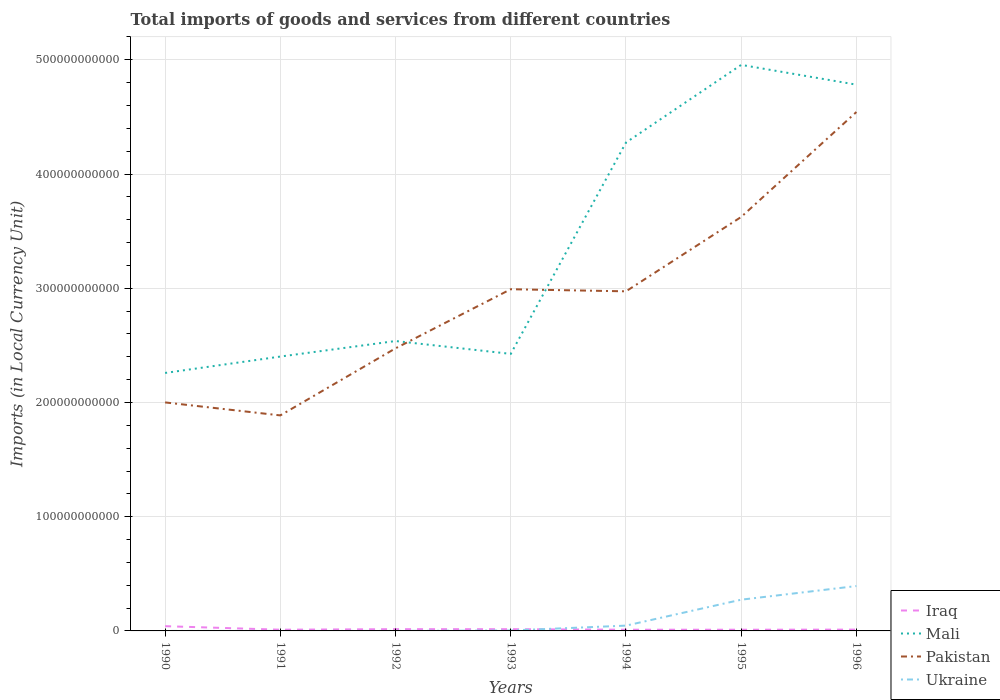How many different coloured lines are there?
Offer a very short reply. 4. Does the line corresponding to Ukraine intersect with the line corresponding to Pakistan?
Your answer should be compact. No. Across all years, what is the maximum Amount of goods and services imports in Mali?
Ensure brevity in your answer.  2.26e+11. What is the total Amount of goods and services imports in Ukraine in the graph?
Ensure brevity in your answer.  -3.93e+1. What is the difference between the highest and the second highest Amount of goods and services imports in Iraq?
Your answer should be compact. 3.11e+09. Is the Amount of goods and services imports in Ukraine strictly greater than the Amount of goods and services imports in Mali over the years?
Ensure brevity in your answer.  Yes. How many lines are there?
Give a very brief answer. 4. What is the difference between two consecutive major ticks on the Y-axis?
Ensure brevity in your answer.  1.00e+11. Does the graph contain any zero values?
Your answer should be very brief. No. Does the graph contain grids?
Give a very brief answer. Yes. How are the legend labels stacked?
Offer a terse response. Vertical. What is the title of the graph?
Provide a succinct answer. Total imports of goods and services from different countries. What is the label or title of the X-axis?
Make the answer very short. Years. What is the label or title of the Y-axis?
Offer a terse response. Imports (in Local Currency Unit). What is the Imports (in Local Currency Unit) of Iraq in 1990?
Your answer should be compact. 4.15e+09. What is the Imports (in Local Currency Unit) of Mali in 1990?
Give a very brief answer. 2.26e+11. What is the Imports (in Local Currency Unit) in Pakistan in 1990?
Make the answer very short. 2.00e+11. What is the Imports (in Local Currency Unit) of Ukraine in 1990?
Make the answer very short. 4.80e+05. What is the Imports (in Local Currency Unit) of Iraq in 1991?
Make the answer very short. 1.06e+09. What is the Imports (in Local Currency Unit) in Mali in 1991?
Make the answer very short. 2.40e+11. What is the Imports (in Local Currency Unit) of Pakistan in 1991?
Offer a terse response. 1.89e+11. What is the Imports (in Local Currency Unit) in Ukraine in 1991?
Offer a terse response. 7.17e+05. What is the Imports (in Local Currency Unit) in Iraq in 1992?
Keep it short and to the point. 1.54e+09. What is the Imports (in Local Currency Unit) of Mali in 1992?
Your response must be concise. 2.54e+11. What is the Imports (in Local Currency Unit) of Pakistan in 1992?
Offer a terse response. 2.47e+11. What is the Imports (in Local Currency Unit) in Ukraine in 1992?
Provide a short and direct response. 1.11e+07. What is the Imports (in Local Currency Unit) of Iraq in 1993?
Give a very brief answer. 1.51e+09. What is the Imports (in Local Currency Unit) of Mali in 1993?
Provide a succinct answer. 2.43e+11. What is the Imports (in Local Currency Unit) of Pakistan in 1993?
Provide a short and direct response. 2.99e+11. What is the Imports (in Local Currency Unit) in Ukraine in 1993?
Ensure brevity in your answer.  3.88e+08. What is the Imports (in Local Currency Unit) of Iraq in 1994?
Ensure brevity in your answer.  1.06e+09. What is the Imports (in Local Currency Unit) of Mali in 1994?
Give a very brief answer. 4.28e+11. What is the Imports (in Local Currency Unit) in Pakistan in 1994?
Make the answer very short. 2.97e+11. What is the Imports (in Local Currency Unit) in Ukraine in 1994?
Your response must be concise. 4.64e+09. What is the Imports (in Local Currency Unit) in Iraq in 1995?
Provide a succinct answer. 1.05e+09. What is the Imports (in Local Currency Unit) of Mali in 1995?
Your answer should be compact. 4.96e+11. What is the Imports (in Local Currency Unit) in Pakistan in 1995?
Give a very brief answer. 3.62e+11. What is the Imports (in Local Currency Unit) of Ukraine in 1995?
Your response must be concise. 2.73e+1. What is the Imports (in Local Currency Unit) of Iraq in 1996?
Ensure brevity in your answer.  1.15e+09. What is the Imports (in Local Currency Unit) in Mali in 1996?
Your answer should be compact. 4.78e+11. What is the Imports (in Local Currency Unit) in Pakistan in 1996?
Your answer should be very brief. 4.54e+11. What is the Imports (in Local Currency Unit) of Ukraine in 1996?
Keep it short and to the point. 3.93e+1. Across all years, what is the maximum Imports (in Local Currency Unit) in Iraq?
Provide a short and direct response. 4.15e+09. Across all years, what is the maximum Imports (in Local Currency Unit) in Mali?
Offer a very short reply. 4.96e+11. Across all years, what is the maximum Imports (in Local Currency Unit) of Pakistan?
Provide a short and direct response. 4.54e+11. Across all years, what is the maximum Imports (in Local Currency Unit) of Ukraine?
Offer a very short reply. 3.93e+1. Across all years, what is the minimum Imports (in Local Currency Unit) of Iraq?
Offer a very short reply. 1.05e+09. Across all years, what is the minimum Imports (in Local Currency Unit) of Mali?
Keep it short and to the point. 2.26e+11. Across all years, what is the minimum Imports (in Local Currency Unit) in Pakistan?
Offer a very short reply. 1.89e+11. Across all years, what is the minimum Imports (in Local Currency Unit) in Ukraine?
Your answer should be very brief. 4.80e+05. What is the total Imports (in Local Currency Unit) in Iraq in the graph?
Keep it short and to the point. 1.15e+1. What is the total Imports (in Local Currency Unit) of Mali in the graph?
Offer a terse response. 2.36e+12. What is the total Imports (in Local Currency Unit) of Pakistan in the graph?
Provide a succinct answer. 2.05e+12. What is the total Imports (in Local Currency Unit) in Ukraine in the graph?
Your answer should be compact. 7.17e+1. What is the difference between the Imports (in Local Currency Unit) of Iraq in 1990 and that in 1991?
Make the answer very short. 3.09e+09. What is the difference between the Imports (in Local Currency Unit) of Mali in 1990 and that in 1991?
Provide a short and direct response. -1.43e+1. What is the difference between the Imports (in Local Currency Unit) of Pakistan in 1990 and that in 1991?
Ensure brevity in your answer.  1.14e+1. What is the difference between the Imports (in Local Currency Unit) of Ukraine in 1990 and that in 1991?
Ensure brevity in your answer.  -2.37e+05. What is the difference between the Imports (in Local Currency Unit) of Iraq in 1990 and that in 1992?
Keep it short and to the point. 2.61e+09. What is the difference between the Imports (in Local Currency Unit) of Mali in 1990 and that in 1992?
Ensure brevity in your answer.  -2.79e+1. What is the difference between the Imports (in Local Currency Unit) in Pakistan in 1990 and that in 1992?
Provide a succinct answer. -4.74e+1. What is the difference between the Imports (in Local Currency Unit) of Ukraine in 1990 and that in 1992?
Provide a succinct answer. -1.06e+07. What is the difference between the Imports (in Local Currency Unit) in Iraq in 1990 and that in 1993?
Offer a very short reply. 2.65e+09. What is the difference between the Imports (in Local Currency Unit) in Mali in 1990 and that in 1993?
Your response must be concise. -1.67e+1. What is the difference between the Imports (in Local Currency Unit) of Pakistan in 1990 and that in 1993?
Provide a short and direct response. -9.91e+1. What is the difference between the Imports (in Local Currency Unit) in Ukraine in 1990 and that in 1993?
Your answer should be very brief. -3.88e+08. What is the difference between the Imports (in Local Currency Unit) in Iraq in 1990 and that in 1994?
Your response must be concise. 3.09e+09. What is the difference between the Imports (in Local Currency Unit) of Mali in 1990 and that in 1994?
Make the answer very short. -2.02e+11. What is the difference between the Imports (in Local Currency Unit) of Pakistan in 1990 and that in 1994?
Your response must be concise. -9.73e+1. What is the difference between the Imports (in Local Currency Unit) of Ukraine in 1990 and that in 1994?
Ensure brevity in your answer.  -4.64e+09. What is the difference between the Imports (in Local Currency Unit) of Iraq in 1990 and that in 1995?
Your answer should be very brief. 3.11e+09. What is the difference between the Imports (in Local Currency Unit) of Mali in 1990 and that in 1995?
Provide a succinct answer. -2.70e+11. What is the difference between the Imports (in Local Currency Unit) of Pakistan in 1990 and that in 1995?
Your response must be concise. -1.62e+11. What is the difference between the Imports (in Local Currency Unit) in Ukraine in 1990 and that in 1995?
Offer a very short reply. -2.73e+1. What is the difference between the Imports (in Local Currency Unit) in Iraq in 1990 and that in 1996?
Offer a terse response. 3.00e+09. What is the difference between the Imports (in Local Currency Unit) of Mali in 1990 and that in 1996?
Your response must be concise. -2.52e+11. What is the difference between the Imports (in Local Currency Unit) in Pakistan in 1990 and that in 1996?
Your answer should be compact. -2.54e+11. What is the difference between the Imports (in Local Currency Unit) in Ukraine in 1990 and that in 1996?
Keep it short and to the point. -3.93e+1. What is the difference between the Imports (in Local Currency Unit) in Iraq in 1991 and that in 1992?
Provide a short and direct response. -4.79e+08. What is the difference between the Imports (in Local Currency Unit) of Mali in 1991 and that in 1992?
Your answer should be compact. -1.36e+1. What is the difference between the Imports (in Local Currency Unit) in Pakistan in 1991 and that in 1992?
Ensure brevity in your answer.  -5.87e+1. What is the difference between the Imports (in Local Currency Unit) of Ukraine in 1991 and that in 1992?
Make the answer very short. -1.04e+07. What is the difference between the Imports (in Local Currency Unit) of Iraq in 1991 and that in 1993?
Provide a short and direct response. -4.47e+08. What is the difference between the Imports (in Local Currency Unit) of Mali in 1991 and that in 1993?
Ensure brevity in your answer.  -2.34e+09. What is the difference between the Imports (in Local Currency Unit) in Pakistan in 1991 and that in 1993?
Your answer should be compact. -1.10e+11. What is the difference between the Imports (in Local Currency Unit) in Ukraine in 1991 and that in 1993?
Give a very brief answer. -3.88e+08. What is the difference between the Imports (in Local Currency Unit) in Mali in 1991 and that in 1994?
Ensure brevity in your answer.  -1.87e+11. What is the difference between the Imports (in Local Currency Unit) of Pakistan in 1991 and that in 1994?
Your answer should be very brief. -1.09e+11. What is the difference between the Imports (in Local Currency Unit) in Ukraine in 1991 and that in 1994?
Your answer should be compact. -4.64e+09. What is the difference between the Imports (in Local Currency Unit) in Iraq in 1991 and that in 1995?
Ensure brevity in your answer.  1.56e+07. What is the difference between the Imports (in Local Currency Unit) of Mali in 1991 and that in 1995?
Make the answer very short. -2.55e+11. What is the difference between the Imports (in Local Currency Unit) in Pakistan in 1991 and that in 1995?
Your answer should be compact. -1.74e+11. What is the difference between the Imports (in Local Currency Unit) of Ukraine in 1991 and that in 1995?
Your answer should be compact. -2.73e+1. What is the difference between the Imports (in Local Currency Unit) of Iraq in 1991 and that in 1996?
Provide a succinct answer. -9.08e+07. What is the difference between the Imports (in Local Currency Unit) of Mali in 1991 and that in 1996?
Offer a very short reply. -2.38e+11. What is the difference between the Imports (in Local Currency Unit) of Pakistan in 1991 and that in 1996?
Provide a short and direct response. -2.66e+11. What is the difference between the Imports (in Local Currency Unit) in Ukraine in 1991 and that in 1996?
Offer a terse response. -3.93e+1. What is the difference between the Imports (in Local Currency Unit) of Iraq in 1992 and that in 1993?
Provide a short and direct response. 3.20e+07. What is the difference between the Imports (in Local Currency Unit) of Mali in 1992 and that in 1993?
Provide a succinct answer. 1.13e+1. What is the difference between the Imports (in Local Currency Unit) of Pakistan in 1992 and that in 1993?
Your answer should be very brief. -5.17e+1. What is the difference between the Imports (in Local Currency Unit) of Ukraine in 1992 and that in 1993?
Your answer should be very brief. -3.77e+08. What is the difference between the Imports (in Local Currency Unit) of Iraq in 1992 and that in 1994?
Offer a very short reply. 4.79e+08. What is the difference between the Imports (in Local Currency Unit) in Mali in 1992 and that in 1994?
Ensure brevity in your answer.  -1.74e+11. What is the difference between the Imports (in Local Currency Unit) in Pakistan in 1992 and that in 1994?
Your answer should be very brief. -4.99e+1. What is the difference between the Imports (in Local Currency Unit) in Ukraine in 1992 and that in 1994?
Your response must be concise. -4.63e+09. What is the difference between the Imports (in Local Currency Unit) of Iraq in 1992 and that in 1995?
Give a very brief answer. 4.95e+08. What is the difference between the Imports (in Local Currency Unit) of Mali in 1992 and that in 1995?
Your answer should be compact. -2.42e+11. What is the difference between the Imports (in Local Currency Unit) of Pakistan in 1992 and that in 1995?
Give a very brief answer. -1.15e+11. What is the difference between the Imports (in Local Currency Unit) of Ukraine in 1992 and that in 1995?
Give a very brief answer. -2.73e+1. What is the difference between the Imports (in Local Currency Unit) in Iraq in 1992 and that in 1996?
Your answer should be compact. 3.89e+08. What is the difference between the Imports (in Local Currency Unit) of Mali in 1992 and that in 1996?
Ensure brevity in your answer.  -2.24e+11. What is the difference between the Imports (in Local Currency Unit) in Pakistan in 1992 and that in 1996?
Ensure brevity in your answer.  -2.07e+11. What is the difference between the Imports (in Local Currency Unit) of Ukraine in 1992 and that in 1996?
Your answer should be very brief. -3.93e+1. What is the difference between the Imports (in Local Currency Unit) in Iraq in 1993 and that in 1994?
Provide a succinct answer. 4.47e+08. What is the difference between the Imports (in Local Currency Unit) of Mali in 1993 and that in 1994?
Offer a terse response. -1.85e+11. What is the difference between the Imports (in Local Currency Unit) of Pakistan in 1993 and that in 1994?
Your response must be concise. 1.84e+09. What is the difference between the Imports (in Local Currency Unit) of Ukraine in 1993 and that in 1994?
Make the answer very short. -4.25e+09. What is the difference between the Imports (in Local Currency Unit) of Iraq in 1993 and that in 1995?
Keep it short and to the point. 4.63e+08. What is the difference between the Imports (in Local Currency Unit) in Mali in 1993 and that in 1995?
Give a very brief answer. -2.53e+11. What is the difference between the Imports (in Local Currency Unit) in Pakistan in 1993 and that in 1995?
Keep it short and to the point. -6.33e+1. What is the difference between the Imports (in Local Currency Unit) of Ukraine in 1993 and that in 1995?
Provide a short and direct response. -2.70e+1. What is the difference between the Imports (in Local Currency Unit) in Iraq in 1993 and that in 1996?
Provide a succinct answer. 3.57e+08. What is the difference between the Imports (in Local Currency Unit) of Mali in 1993 and that in 1996?
Your answer should be compact. -2.36e+11. What is the difference between the Imports (in Local Currency Unit) of Pakistan in 1993 and that in 1996?
Make the answer very short. -1.55e+11. What is the difference between the Imports (in Local Currency Unit) in Ukraine in 1993 and that in 1996?
Give a very brief answer. -3.89e+1. What is the difference between the Imports (in Local Currency Unit) in Iraq in 1994 and that in 1995?
Your answer should be compact. 1.56e+07. What is the difference between the Imports (in Local Currency Unit) in Mali in 1994 and that in 1995?
Offer a terse response. -6.80e+1. What is the difference between the Imports (in Local Currency Unit) in Pakistan in 1994 and that in 1995?
Keep it short and to the point. -6.51e+1. What is the difference between the Imports (in Local Currency Unit) of Ukraine in 1994 and that in 1995?
Provide a short and direct response. -2.27e+1. What is the difference between the Imports (in Local Currency Unit) of Iraq in 1994 and that in 1996?
Make the answer very short. -9.08e+07. What is the difference between the Imports (in Local Currency Unit) of Mali in 1994 and that in 1996?
Your answer should be compact. -5.07e+1. What is the difference between the Imports (in Local Currency Unit) in Pakistan in 1994 and that in 1996?
Ensure brevity in your answer.  -1.57e+11. What is the difference between the Imports (in Local Currency Unit) of Ukraine in 1994 and that in 1996?
Keep it short and to the point. -3.47e+1. What is the difference between the Imports (in Local Currency Unit) of Iraq in 1995 and that in 1996?
Make the answer very short. -1.06e+08. What is the difference between the Imports (in Local Currency Unit) in Mali in 1995 and that in 1996?
Keep it short and to the point. 1.73e+1. What is the difference between the Imports (in Local Currency Unit) in Pakistan in 1995 and that in 1996?
Provide a short and direct response. -9.19e+1. What is the difference between the Imports (in Local Currency Unit) of Ukraine in 1995 and that in 1996?
Offer a very short reply. -1.20e+1. What is the difference between the Imports (in Local Currency Unit) in Iraq in 1990 and the Imports (in Local Currency Unit) in Mali in 1991?
Make the answer very short. -2.36e+11. What is the difference between the Imports (in Local Currency Unit) of Iraq in 1990 and the Imports (in Local Currency Unit) of Pakistan in 1991?
Keep it short and to the point. -1.85e+11. What is the difference between the Imports (in Local Currency Unit) of Iraq in 1990 and the Imports (in Local Currency Unit) of Ukraine in 1991?
Your answer should be very brief. 4.15e+09. What is the difference between the Imports (in Local Currency Unit) in Mali in 1990 and the Imports (in Local Currency Unit) in Pakistan in 1991?
Offer a terse response. 3.72e+1. What is the difference between the Imports (in Local Currency Unit) of Mali in 1990 and the Imports (in Local Currency Unit) of Ukraine in 1991?
Provide a succinct answer. 2.26e+11. What is the difference between the Imports (in Local Currency Unit) in Pakistan in 1990 and the Imports (in Local Currency Unit) in Ukraine in 1991?
Make the answer very short. 2.00e+11. What is the difference between the Imports (in Local Currency Unit) of Iraq in 1990 and the Imports (in Local Currency Unit) of Mali in 1992?
Offer a very short reply. -2.50e+11. What is the difference between the Imports (in Local Currency Unit) in Iraq in 1990 and the Imports (in Local Currency Unit) in Pakistan in 1992?
Offer a terse response. -2.43e+11. What is the difference between the Imports (in Local Currency Unit) in Iraq in 1990 and the Imports (in Local Currency Unit) in Ukraine in 1992?
Give a very brief answer. 4.14e+09. What is the difference between the Imports (in Local Currency Unit) of Mali in 1990 and the Imports (in Local Currency Unit) of Pakistan in 1992?
Ensure brevity in your answer.  -2.16e+1. What is the difference between the Imports (in Local Currency Unit) in Mali in 1990 and the Imports (in Local Currency Unit) in Ukraine in 1992?
Give a very brief answer. 2.26e+11. What is the difference between the Imports (in Local Currency Unit) in Pakistan in 1990 and the Imports (in Local Currency Unit) in Ukraine in 1992?
Offer a terse response. 2.00e+11. What is the difference between the Imports (in Local Currency Unit) in Iraq in 1990 and the Imports (in Local Currency Unit) in Mali in 1993?
Provide a succinct answer. -2.38e+11. What is the difference between the Imports (in Local Currency Unit) of Iraq in 1990 and the Imports (in Local Currency Unit) of Pakistan in 1993?
Provide a succinct answer. -2.95e+11. What is the difference between the Imports (in Local Currency Unit) in Iraq in 1990 and the Imports (in Local Currency Unit) in Ukraine in 1993?
Provide a short and direct response. 3.77e+09. What is the difference between the Imports (in Local Currency Unit) of Mali in 1990 and the Imports (in Local Currency Unit) of Pakistan in 1993?
Make the answer very short. -7.33e+1. What is the difference between the Imports (in Local Currency Unit) of Mali in 1990 and the Imports (in Local Currency Unit) of Ukraine in 1993?
Provide a short and direct response. 2.25e+11. What is the difference between the Imports (in Local Currency Unit) in Pakistan in 1990 and the Imports (in Local Currency Unit) in Ukraine in 1993?
Offer a terse response. 2.00e+11. What is the difference between the Imports (in Local Currency Unit) in Iraq in 1990 and the Imports (in Local Currency Unit) in Mali in 1994?
Make the answer very short. -4.23e+11. What is the difference between the Imports (in Local Currency Unit) in Iraq in 1990 and the Imports (in Local Currency Unit) in Pakistan in 1994?
Give a very brief answer. -2.93e+11. What is the difference between the Imports (in Local Currency Unit) of Iraq in 1990 and the Imports (in Local Currency Unit) of Ukraine in 1994?
Your response must be concise. -4.87e+08. What is the difference between the Imports (in Local Currency Unit) of Mali in 1990 and the Imports (in Local Currency Unit) of Pakistan in 1994?
Your response must be concise. -7.15e+1. What is the difference between the Imports (in Local Currency Unit) in Mali in 1990 and the Imports (in Local Currency Unit) in Ukraine in 1994?
Your answer should be compact. 2.21e+11. What is the difference between the Imports (in Local Currency Unit) in Pakistan in 1990 and the Imports (in Local Currency Unit) in Ukraine in 1994?
Make the answer very short. 1.95e+11. What is the difference between the Imports (in Local Currency Unit) of Iraq in 1990 and the Imports (in Local Currency Unit) of Mali in 1995?
Offer a terse response. -4.91e+11. What is the difference between the Imports (in Local Currency Unit) in Iraq in 1990 and the Imports (in Local Currency Unit) in Pakistan in 1995?
Provide a short and direct response. -3.58e+11. What is the difference between the Imports (in Local Currency Unit) of Iraq in 1990 and the Imports (in Local Currency Unit) of Ukraine in 1995?
Make the answer very short. -2.32e+1. What is the difference between the Imports (in Local Currency Unit) in Mali in 1990 and the Imports (in Local Currency Unit) in Pakistan in 1995?
Your response must be concise. -1.37e+11. What is the difference between the Imports (in Local Currency Unit) in Mali in 1990 and the Imports (in Local Currency Unit) in Ukraine in 1995?
Offer a terse response. 1.99e+11. What is the difference between the Imports (in Local Currency Unit) of Pakistan in 1990 and the Imports (in Local Currency Unit) of Ukraine in 1995?
Your answer should be very brief. 1.73e+11. What is the difference between the Imports (in Local Currency Unit) in Iraq in 1990 and the Imports (in Local Currency Unit) in Mali in 1996?
Make the answer very short. -4.74e+11. What is the difference between the Imports (in Local Currency Unit) of Iraq in 1990 and the Imports (in Local Currency Unit) of Pakistan in 1996?
Your answer should be compact. -4.50e+11. What is the difference between the Imports (in Local Currency Unit) of Iraq in 1990 and the Imports (in Local Currency Unit) of Ukraine in 1996?
Your response must be concise. -3.51e+1. What is the difference between the Imports (in Local Currency Unit) of Mali in 1990 and the Imports (in Local Currency Unit) of Pakistan in 1996?
Your response must be concise. -2.28e+11. What is the difference between the Imports (in Local Currency Unit) in Mali in 1990 and the Imports (in Local Currency Unit) in Ukraine in 1996?
Offer a terse response. 1.87e+11. What is the difference between the Imports (in Local Currency Unit) of Pakistan in 1990 and the Imports (in Local Currency Unit) of Ukraine in 1996?
Give a very brief answer. 1.61e+11. What is the difference between the Imports (in Local Currency Unit) of Iraq in 1991 and the Imports (in Local Currency Unit) of Mali in 1992?
Provide a succinct answer. -2.53e+11. What is the difference between the Imports (in Local Currency Unit) of Iraq in 1991 and the Imports (in Local Currency Unit) of Pakistan in 1992?
Your answer should be very brief. -2.46e+11. What is the difference between the Imports (in Local Currency Unit) of Iraq in 1991 and the Imports (in Local Currency Unit) of Ukraine in 1992?
Your answer should be very brief. 1.05e+09. What is the difference between the Imports (in Local Currency Unit) in Mali in 1991 and the Imports (in Local Currency Unit) in Pakistan in 1992?
Offer a terse response. -7.21e+09. What is the difference between the Imports (in Local Currency Unit) in Mali in 1991 and the Imports (in Local Currency Unit) in Ukraine in 1992?
Your answer should be compact. 2.40e+11. What is the difference between the Imports (in Local Currency Unit) in Pakistan in 1991 and the Imports (in Local Currency Unit) in Ukraine in 1992?
Make the answer very short. 1.89e+11. What is the difference between the Imports (in Local Currency Unit) of Iraq in 1991 and the Imports (in Local Currency Unit) of Mali in 1993?
Provide a succinct answer. -2.41e+11. What is the difference between the Imports (in Local Currency Unit) in Iraq in 1991 and the Imports (in Local Currency Unit) in Pakistan in 1993?
Your response must be concise. -2.98e+11. What is the difference between the Imports (in Local Currency Unit) in Iraq in 1991 and the Imports (in Local Currency Unit) in Ukraine in 1993?
Provide a succinct answer. 6.73e+08. What is the difference between the Imports (in Local Currency Unit) in Mali in 1991 and the Imports (in Local Currency Unit) in Pakistan in 1993?
Ensure brevity in your answer.  -5.89e+1. What is the difference between the Imports (in Local Currency Unit) of Mali in 1991 and the Imports (in Local Currency Unit) of Ukraine in 1993?
Offer a very short reply. 2.40e+11. What is the difference between the Imports (in Local Currency Unit) of Pakistan in 1991 and the Imports (in Local Currency Unit) of Ukraine in 1993?
Provide a short and direct response. 1.88e+11. What is the difference between the Imports (in Local Currency Unit) of Iraq in 1991 and the Imports (in Local Currency Unit) of Mali in 1994?
Your answer should be compact. -4.27e+11. What is the difference between the Imports (in Local Currency Unit) of Iraq in 1991 and the Imports (in Local Currency Unit) of Pakistan in 1994?
Your answer should be very brief. -2.96e+11. What is the difference between the Imports (in Local Currency Unit) of Iraq in 1991 and the Imports (in Local Currency Unit) of Ukraine in 1994?
Provide a succinct answer. -3.58e+09. What is the difference between the Imports (in Local Currency Unit) of Mali in 1991 and the Imports (in Local Currency Unit) of Pakistan in 1994?
Your answer should be compact. -5.71e+1. What is the difference between the Imports (in Local Currency Unit) in Mali in 1991 and the Imports (in Local Currency Unit) in Ukraine in 1994?
Make the answer very short. 2.36e+11. What is the difference between the Imports (in Local Currency Unit) of Pakistan in 1991 and the Imports (in Local Currency Unit) of Ukraine in 1994?
Ensure brevity in your answer.  1.84e+11. What is the difference between the Imports (in Local Currency Unit) in Iraq in 1991 and the Imports (in Local Currency Unit) in Mali in 1995?
Make the answer very short. -4.94e+11. What is the difference between the Imports (in Local Currency Unit) in Iraq in 1991 and the Imports (in Local Currency Unit) in Pakistan in 1995?
Offer a terse response. -3.61e+11. What is the difference between the Imports (in Local Currency Unit) of Iraq in 1991 and the Imports (in Local Currency Unit) of Ukraine in 1995?
Your answer should be compact. -2.63e+1. What is the difference between the Imports (in Local Currency Unit) of Mali in 1991 and the Imports (in Local Currency Unit) of Pakistan in 1995?
Your answer should be very brief. -1.22e+11. What is the difference between the Imports (in Local Currency Unit) of Mali in 1991 and the Imports (in Local Currency Unit) of Ukraine in 1995?
Your response must be concise. 2.13e+11. What is the difference between the Imports (in Local Currency Unit) in Pakistan in 1991 and the Imports (in Local Currency Unit) in Ukraine in 1995?
Your response must be concise. 1.61e+11. What is the difference between the Imports (in Local Currency Unit) in Iraq in 1991 and the Imports (in Local Currency Unit) in Mali in 1996?
Keep it short and to the point. -4.77e+11. What is the difference between the Imports (in Local Currency Unit) of Iraq in 1991 and the Imports (in Local Currency Unit) of Pakistan in 1996?
Your answer should be compact. -4.53e+11. What is the difference between the Imports (in Local Currency Unit) in Iraq in 1991 and the Imports (in Local Currency Unit) in Ukraine in 1996?
Your answer should be very brief. -3.82e+1. What is the difference between the Imports (in Local Currency Unit) of Mali in 1991 and the Imports (in Local Currency Unit) of Pakistan in 1996?
Your answer should be very brief. -2.14e+11. What is the difference between the Imports (in Local Currency Unit) in Mali in 1991 and the Imports (in Local Currency Unit) in Ukraine in 1996?
Give a very brief answer. 2.01e+11. What is the difference between the Imports (in Local Currency Unit) of Pakistan in 1991 and the Imports (in Local Currency Unit) of Ukraine in 1996?
Make the answer very short. 1.49e+11. What is the difference between the Imports (in Local Currency Unit) of Iraq in 1992 and the Imports (in Local Currency Unit) of Mali in 1993?
Keep it short and to the point. -2.41e+11. What is the difference between the Imports (in Local Currency Unit) in Iraq in 1992 and the Imports (in Local Currency Unit) in Pakistan in 1993?
Offer a terse response. -2.98e+11. What is the difference between the Imports (in Local Currency Unit) in Iraq in 1992 and the Imports (in Local Currency Unit) in Ukraine in 1993?
Keep it short and to the point. 1.15e+09. What is the difference between the Imports (in Local Currency Unit) in Mali in 1992 and the Imports (in Local Currency Unit) in Pakistan in 1993?
Keep it short and to the point. -4.54e+1. What is the difference between the Imports (in Local Currency Unit) in Mali in 1992 and the Imports (in Local Currency Unit) in Ukraine in 1993?
Your response must be concise. 2.53e+11. What is the difference between the Imports (in Local Currency Unit) of Pakistan in 1992 and the Imports (in Local Currency Unit) of Ukraine in 1993?
Provide a short and direct response. 2.47e+11. What is the difference between the Imports (in Local Currency Unit) of Iraq in 1992 and the Imports (in Local Currency Unit) of Mali in 1994?
Your answer should be very brief. -4.26e+11. What is the difference between the Imports (in Local Currency Unit) of Iraq in 1992 and the Imports (in Local Currency Unit) of Pakistan in 1994?
Make the answer very short. -2.96e+11. What is the difference between the Imports (in Local Currency Unit) in Iraq in 1992 and the Imports (in Local Currency Unit) in Ukraine in 1994?
Your response must be concise. -3.10e+09. What is the difference between the Imports (in Local Currency Unit) in Mali in 1992 and the Imports (in Local Currency Unit) in Pakistan in 1994?
Your answer should be compact. -4.35e+1. What is the difference between the Imports (in Local Currency Unit) of Mali in 1992 and the Imports (in Local Currency Unit) of Ukraine in 1994?
Provide a short and direct response. 2.49e+11. What is the difference between the Imports (in Local Currency Unit) of Pakistan in 1992 and the Imports (in Local Currency Unit) of Ukraine in 1994?
Keep it short and to the point. 2.43e+11. What is the difference between the Imports (in Local Currency Unit) in Iraq in 1992 and the Imports (in Local Currency Unit) in Mali in 1995?
Your answer should be very brief. -4.94e+11. What is the difference between the Imports (in Local Currency Unit) of Iraq in 1992 and the Imports (in Local Currency Unit) of Pakistan in 1995?
Offer a terse response. -3.61e+11. What is the difference between the Imports (in Local Currency Unit) of Iraq in 1992 and the Imports (in Local Currency Unit) of Ukraine in 1995?
Give a very brief answer. -2.58e+1. What is the difference between the Imports (in Local Currency Unit) of Mali in 1992 and the Imports (in Local Currency Unit) of Pakistan in 1995?
Offer a very short reply. -1.09e+11. What is the difference between the Imports (in Local Currency Unit) in Mali in 1992 and the Imports (in Local Currency Unit) in Ukraine in 1995?
Make the answer very short. 2.26e+11. What is the difference between the Imports (in Local Currency Unit) in Pakistan in 1992 and the Imports (in Local Currency Unit) in Ukraine in 1995?
Provide a short and direct response. 2.20e+11. What is the difference between the Imports (in Local Currency Unit) of Iraq in 1992 and the Imports (in Local Currency Unit) of Mali in 1996?
Keep it short and to the point. -4.77e+11. What is the difference between the Imports (in Local Currency Unit) of Iraq in 1992 and the Imports (in Local Currency Unit) of Pakistan in 1996?
Your response must be concise. -4.53e+11. What is the difference between the Imports (in Local Currency Unit) in Iraq in 1992 and the Imports (in Local Currency Unit) in Ukraine in 1996?
Your answer should be compact. -3.78e+1. What is the difference between the Imports (in Local Currency Unit) in Mali in 1992 and the Imports (in Local Currency Unit) in Pakistan in 1996?
Ensure brevity in your answer.  -2.00e+11. What is the difference between the Imports (in Local Currency Unit) in Mali in 1992 and the Imports (in Local Currency Unit) in Ukraine in 1996?
Keep it short and to the point. 2.14e+11. What is the difference between the Imports (in Local Currency Unit) of Pakistan in 1992 and the Imports (in Local Currency Unit) of Ukraine in 1996?
Provide a succinct answer. 2.08e+11. What is the difference between the Imports (in Local Currency Unit) in Iraq in 1993 and the Imports (in Local Currency Unit) in Mali in 1994?
Make the answer very short. -4.26e+11. What is the difference between the Imports (in Local Currency Unit) in Iraq in 1993 and the Imports (in Local Currency Unit) in Pakistan in 1994?
Your answer should be very brief. -2.96e+11. What is the difference between the Imports (in Local Currency Unit) in Iraq in 1993 and the Imports (in Local Currency Unit) in Ukraine in 1994?
Your answer should be very brief. -3.13e+09. What is the difference between the Imports (in Local Currency Unit) in Mali in 1993 and the Imports (in Local Currency Unit) in Pakistan in 1994?
Provide a short and direct response. -5.48e+1. What is the difference between the Imports (in Local Currency Unit) in Mali in 1993 and the Imports (in Local Currency Unit) in Ukraine in 1994?
Your response must be concise. 2.38e+11. What is the difference between the Imports (in Local Currency Unit) of Pakistan in 1993 and the Imports (in Local Currency Unit) of Ukraine in 1994?
Give a very brief answer. 2.95e+11. What is the difference between the Imports (in Local Currency Unit) in Iraq in 1993 and the Imports (in Local Currency Unit) in Mali in 1995?
Ensure brevity in your answer.  -4.94e+11. What is the difference between the Imports (in Local Currency Unit) of Iraq in 1993 and the Imports (in Local Currency Unit) of Pakistan in 1995?
Your response must be concise. -3.61e+11. What is the difference between the Imports (in Local Currency Unit) in Iraq in 1993 and the Imports (in Local Currency Unit) in Ukraine in 1995?
Keep it short and to the point. -2.58e+1. What is the difference between the Imports (in Local Currency Unit) in Mali in 1993 and the Imports (in Local Currency Unit) in Pakistan in 1995?
Give a very brief answer. -1.20e+11. What is the difference between the Imports (in Local Currency Unit) of Mali in 1993 and the Imports (in Local Currency Unit) of Ukraine in 1995?
Provide a succinct answer. 2.15e+11. What is the difference between the Imports (in Local Currency Unit) in Pakistan in 1993 and the Imports (in Local Currency Unit) in Ukraine in 1995?
Provide a succinct answer. 2.72e+11. What is the difference between the Imports (in Local Currency Unit) in Iraq in 1993 and the Imports (in Local Currency Unit) in Mali in 1996?
Your response must be concise. -4.77e+11. What is the difference between the Imports (in Local Currency Unit) of Iraq in 1993 and the Imports (in Local Currency Unit) of Pakistan in 1996?
Your answer should be compact. -4.53e+11. What is the difference between the Imports (in Local Currency Unit) of Iraq in 1993 and the Imports (in Local Currency Unit) of Ukraine in 1996?
Make the answer very short. -3.78e+1. What is the difference between the Imports (in Local Currency Unit) in Mali in 1993 and the Imports (in Local Currency Unit) in Pakistan in 1996?
Your answer should be compact. -2.12e+11. What is the difference between the Imports (in Local Currency Unit) of Mali in 1993 and the Imports (in Local Currency Unit) of Ukraine in 1996?
Provide a short and direct response. 2.03e+11. What is the difference between the Imports (in Local Currency Unit) in Pakistan in 1993 and the Imports (in Local Currency Unit) in Ukraine in 1996?
Keep it short and to the point. 2.60e+11. What is the difference between the Imports (in Local Currency Unit) in Iraq in 1994 and the Imports (in Local Currency Unit) in Mali in 1995?
Keep it short and to the point. -4.94e+11. What is the difference between the Imports (in Local Currency Unit) of Iraq in 1994 and the Imports (in Local Currency Unit) of Pakistan in 1995?
Keep it short and to the point. -3.61e+11. What is the difference between the Imports (in Local Currency Unit) in Iraq in 1994 and the Imports (in Local Currency Unit) in Ukraine in 1995?
Offer a terse response. -2.63e+1. What is the difference between the Imports (in Local Currency Unit) of Mali in 1994 and the Imports (in Local Currency Unit) of Pakistan in 1995?
Ensure brevity in your answer.  6.52e+1. What is the difference between the Imports (in Local Currency Unit) in Mali in 1994 and the Imports (in Local Currency Unit) in Ukraine in 1995?
Keep it short and to the point. 4.00e+11. What is the difference between the Imports (in Local Currency Unit) of Pakistan in 1994 and the Imports (in Local Currency Unit) of Ukraine in 1995?
Give a very brief answer. 2.70e+11. What is the difference between the Imports (in Local Currency Unit) in Iraq in 1994 and the Imports (in Local Currency Unit) in Mali in 1996?
Provide a short and direct response. -4.77e+11. What is the difference between the Imports (in Local Currency Unit) in Iraq in 1994 and the Imports (in Local Currency Unit) in Pakistan in 1996?
Make the answer very short. -4.53e+11. What is the difference between the Imports (in Local Currency Unit) in Iraq in 1994 and the Imports (in Local Currency Unit) in Ukraine in 1996?
Your answer should be compact. -3.82e+1. What is the difference between the Imports (in Local Currency Unit) of Mali in 1994 and the Imports (in Local Currency Unit) of Pakistan in 1996?
Provide a short and direct response. -2.67e+1. What is the difference between the Imports (in Local Currency Unit) of Mali in 1994 and the Imports (in Local Currency Unit) of Ukraine in 1996?
Make the answer very short. 3.88e+11. What is the difference between the Imports (in Local Currency Unit) in Pakistan in 1994 and the Imports (in Local Currency Unit) in Ukraine in 1996?
Ensure brevity in your answer.  2.58e+11. What is the difference between the Imports (in Local Currency Unit) in Iraq in 1995 and the Imports (in Local Currency Unit) in Mali in 1996?
Provide a short and direct response. -4.77e+11. What is the difference between the Imports (in Local Currency Unit) of Iraq in 1995 and the Imports (in Local Currency Unit) of Pakistan in 1996?
Provide a succinct answer. -4.53e+11. What is the difference between the Imports (in Local Currency Unit) in Iraq in 1995 and the Imports (in Local Currency Unit) in Ukraine in 1996?
Offer a terse response. -3.82e+1. What is the difference between the Imports (in Local Currency Unit) in Mali in 1995 and the Imports (in Local Currency Unit) in Pakistan in 1996?
Your answer should be very brief. 4.13e+1. What is the difference between the Imports (in Local Currency Unit) of Mali in 1995 and the Imports (in Local Currency Unit) of Ukraine in 1996?
Your response must be concise. 4.56e+11. What is the difference between the Imports (in Local Currency Unit) of Pakistan in 1995 and the Imports (in Local Currency Unit) of Ukraine in 1996?
Keep it short and to the point. 3.23e+11. What is the average Imports (in Local Currency Unit) in Iraq per year?
Give a very brief answer. 1.65e+09. What is the average Imports (in Local Currency Unit) in Mali per year?
Provide a short and direct response. 3.38e+11. What is the average Imports (in Local Currency Unit) of Pakistan per year?
Offer a very short reply. 2.93e+11. What is the average Imports (in Local Currency Unit) in Ukraine per year?
Ensure brevity in your answer.  1.02e+1. In the year 1990, what is the difference between the Imports (in Local Currency Unit) of Iraq and Imports (in Local Currency Unit) of Mali?
Keep it short and to the point. -2.22e+11. In the year 1990, what is the difference between the Imports (in Local Currency Unit) of Iraq and Imports (in Local Currency Unit) of Pakistan?
Give a very brief answer. -1.96e+11. In the year 1990, what is the difference between the Imports (in Local Currency Unit) of Iraq and Imports (in Local Currency Unit) of Ukraine?
Your response must be concise. 4.15e+09. In the year 1990, what is the difference between the Imports (in Local Currency Unit) in Mali and Imports (in Local Currency Unit) in Pakistan?
Offer a terse response. 2.58e+1. In the year 1990, what is the difference between the Imports (in Local Currency Unit) of Mali and Imports (in Local Currency Unit) of Ukraine?
Make the answer very short. 2.26e+11. In the year 1990, what is the difference between the Imports (in Local Currency Unit) in Pakistan and Imports (in Local Currency Unit) in Ukraine?
Keep it short and to the point. 2.00e+11. In the year 1991, what is the difference between the Imports (in Local Currency Unit) of Iraq and Imports (in Local Currency Unit) of Mali?
Make the answer very short. -2.39e+11. In the year 1991, what is the difference between the Imports (in Local Currency Unit) of Iraq and Imports (in Local Currency Unit) of Pakistan?
Make the answer very short. -1.88e+11. In the year 1991, what is the difference between the Imports (in Local Currency Unit) in Iraq and Imports (in Local Currency Unit) in Ukraine?
Make the answer very short. 1.06e+09. In the year 1991, what is the difference between the Imports (in Local Currency Unit) in Mali and Imports (in Local Currency Unit) in Pakistan?
Ensure brevity in your answer.  5.15e+1. In the year 1991, what is the difference between the Imports (in Local Currency Unit) of Mali and Imports (in Local Currency Unit) of Ukraine?
Your response must be concise. 2.40e+11. In the year 1991, what is the difference between the Imports (in Local Currency Unit) of Pakistan and Imports (in Local Currency Unit) of Ukraine?
Keep it short and to the point. 1.89e+11. In the year 1992, what is the difference between the Imports (in Local Currency Unit) in Iraq and Imports (in Local Currency Unit) in Mali?
Provide a succinct answer. -2.52e+11. In the year 1992, what is the difference between the Imports (in Local Currency Unit) in Iraq and Imports (in Local Currency Unit) in Pakistan?
Offer a terse response. -2.46e+11. In the year 1992, what is the difference between the Imports (in Local Currency Unit) in Iraq and Imports (in Local Currency Unit) in Ukraine?
Your response must be concise. 1.53e+09. In the year 1992, what is the difference between the Imports (in Local Currency Unit) in Mali and Imports (in Local Currency Unit) in Pakistan?
Provide a succinct answer. 6.38e+09. In the year 1992, what is the difference between the Imports (in Local Currency Unit) of Mali and Imports (in Local Currency Unit) of Ukraine?
Offer a terse response. 2.54e+11. In the year 1992, what is the difference between the Imports (in Local Currency Unit) in Pakistan and Imports (in Local Currency Unit) in Ukraine?
Offer a terse response. 2.47e+11. In the year 1993, what is the difference between the Imports (in Local Currency Unit) in Iraq and Imports (in Local Currency Unit) in Mali?
Make the answer very short. -2.41e+11. In the year 1993, what is the difference between the Imports (in Local Currency Unit) in Iraq and Imports (in Local Currency Unit) in Pakistan?
Provide a succinct answer. -2.98e+11. In the year 1993, what is the difference between the Imports (in Local Currency Unit) in Iraq and Imports (in Local Currency Unit) in Ukraine?
Your answer should be compact. 1.12e+09. In the year 1993, what is the difference between the Imports (in Local Currency Unit) in Mali and Imports (in Local Currency Unit) in Pakistan?
Offer a very short reply. -5.66e+1. In the year 1993, what is the difference between the Imports (in Local Currency Unit) of Mali and Imports (in Local Currency Unit) of Ukraine?
Offer a very short reply. 2.42e+11. In the year 1993, what is the difference between the Imports (in Local Currency Unit) of Pakistan and Imports (in Local Currency Unit) of Ukraine?
Your answer should be very brief. 2.99e+11. In the year 1994, what is the difference between the Imports (in Local Currency Unit) in Iraq and Imports (in Local Currency Unit) in Mali?
Offer a very short reply. -4.27e+11. In the year 1994, what is the difference between the Imports (in Local Currency Unit) in Iraq and Imports (in Local Currency Unit) in Pakistan?
Your answer should be very brief. -2.96e+11. In the year 1994, what is the difference between the Imports (in Local Currency Unit) in Iraq and Imports (in Local Currency Unit) in Ukraine?
Your answer should be very brief. -3.58e+09. In the year 1994, what is the difference between the Imports (in Local Currency Unit) in Mali and Imports (in Local Currency Unit) in Pakistan?
Provide a short and direct response. 1.30e+11. In the year 1994, what is the difference between the Imports (in Local Currency Unit) of Mali and Imports (in Local Currency Unit) of Ukraine?
Keep it short and to the point. 4.23e+11. In the year 1994, what is the difference between the Imports (in Local Currency Unit) in Pakistan and Imports (in Local Currency Unit) in Ukraine?
Provide a short and direct response. 2.93e+11. In the year 1995, what is the difference between the Imports (in Local Currency Unit) in Iraq and Imports (in Local Currency Unit) in Mali?
Your answer should be compact. -4.95e+11. In the year 1995, what is the difference between the Imports (in Local Currency Unit) in Iraq and Imports (in Local Currency Unit) in Pakistan?
Give a very brief answer. -3.61e+11. In the year 1995, what is the difference between the Imports (in Local Currency Unit) of Iraq and Imports (in Local Currency Unit) of Ukraine?
Give a very brief answer. -2.63e+1. In the year 1995, what is the difference between the Imports (in Local Currency Unit) in Mali and Imports (in Local Currency Unit) in Pakistan?
Keep it short and to the point. 1.33e+11. In the year 1995, what is the difference between the Imports (in Local Currency Unit) of Mali and Imports (in Local Currency Unit) of Ukraine?
Keep it short and to the point. 4.68e+11. In the year 1995, what is the difference between the Imports (in Local Currency Unit) in Pakistan and Imports (in Local Currency Unit) in Ukraine?
Keep it short and to the point. 3.35e+11. In the year 1996, what is the difference between the Imports (in Local Currency Unit) in Iraq and Imports (in Local Currency Unit) in Mali?
Your answer should be very brief. -4.77e+11. In the year 1996, what is the difference between the Imports (in Local Currency Unit) in Iraq and Imports (in Local Currency Unit) in Pakistan?
Your answer should be compact. -4.53e+11. In the year 1996, what is the difference between the Imports (in Local Currency Unit) in Iraq and Imports (in Local Currency Unit) in Ukraine?
Your answer should be very brief. -3.81e+1. In the year 1996, what is the difference between the Imports (in Local Currency Unit) of Mali and Imports (in Local Currency Unit) of Pakistan?
Provide a short and direct response. 2.39e+1. In the year 1996, what is the difference between the Imports (in Local Currency Unit) in Mali and Imports (in Local Currency Unit) in Ukraine?
Keep it short and to the point. 4.39e+11. In the year 1996, what is the difference between the Imports (in Local Currency Unit) of Pakistan and Imports (in Local Currency Unit) of Ukraine?
Keep it short and to the point. 4.15e+11. What is the ratio of the Imports (in Local Currency Unit) of Iraq in 1990 to that in 1991?
Your response must be concise. 3.91. What is the ratio of the Imports (in Local Currency Unit) in Mali in 1990 to that in 1991?
Provide a short and direct response. 0.94. What is the ratio of the Imports (in Local Currency Unit) in Pakistan in 1990 to that in 1991?
Your answer should be compact. 1.06. What is the ratio of the Imports (in Local Currency Unit) of Ukraine in 1990 to that in 1991?
Provide a short and direct response. 0.67. What is the ratio of the Imports (in Local Currency Unit) in Iraq in 1990 to that in 1992?
Offer a terse response. 2.7. What is the ratio of the Imports (in Local Currency Unit) in Mali in 1990 to that in 1992?
Offer a terse response. 0.89. What is the ratio of the Imports (in Local Currency Unit) of Pakistan in 1990 to that in 1992?
Make the answer very short. 0.81. What is the ratio of the Imports (in Local Currency Unit) of Ukraine in 1990 to that in 1992?
Give a very brief answer. 0.04. What is the ratio of the Imports (in Local Currency Unit) of Iraq in 1990 to that in 1993?
Your answer should be compact. 2.75. What is the ratio of the Imports (in Local Currency Unit) in Mali in 1990 to that in 1993?
Give a very brief answer. 0.93. What is the ratio of the Imports (in Local Currency Unit) in Pakistan in 1990 to that in 1993?
Ensure brevity in your answer.  0.67. What is the ratio of the Imports (in Local Currency Unit) of Ukraine in 1990 to that in 1993?
Provide a succinct answer. 0. What is the ratio of the Imports (in Local Currency Unit) of Iraq in 1990 to that in 1994?
Ensure brevity in your answer.  3.91. What is the ratio of the Imports (in Local Currency Unit) in Mali in 1990 to that in 1994?
Provide a succinct answer. 0.53. What is the ratio of the Imports (in Local Currency Unit) of Pakistan in 1990 to that in 1994?
Your response must be concise. 0.67. What is the ratio of the Imports (in Local Currency Unit) in Ukraine in 1990 to that in 1994?
Offer a terse response. 0. What is the ratio of the Imports (in Local Currency Unit) of Iraq in 1990 to that in 1995?
Your answer should be compact. 3.97. What is the ratio of the Imports (in Local Currency Unit) in Mali in 1990 to that in 1995?
Offer a very short reply. 0.46. What is the ratio of the Imports (in Local Currency Unit) of Pakistan in 1990 to that in 1995?
Ensure brevity in your answer.  0.55. What is the ratio of the Imports (in Local Currency Unit) of Iraq in 1990 to that in 1996?
Ensure brevity in your answer.  3.6. What is the ratio of the Imports (in Local Currency Unit) in Mali in 1990 to that in 1996?
Your answer should be compact. 0.47. What is the ratio of the Imports (in Local Currency Unit) in Pakistan in 1990 to that in 1996?
Your answer should be very brief. 0.44. What is the ratio of the Imports (in Local Currency Unit) in Iraq in 1991 to that in 1992?
Your answer should be very brief. 0.69. What is the ratio of the Imports (in Local Currency Unit) of Mali in 1991 to that in 1992?
Provide a succinct answer. 0.95. What is the ratio of the Imports (in Local Currency Unit) of Pakistan in 1991 to that in 1992?
Offer a very short reply. 0.76. What is the ratio of the Imports (in Local Currency Unit) in Ukraine in 1991 to that in 1992?
Ensure brevity in your answer.  0.06. What is the ratio of the Imports (in Local Currency Unit) in Iraq in 1991 to that in 1993?
Your response must be concise. 0.7. What is the ratio of the Imports (in Local Currency Unit) of Pakistan in 1991 to that in 1993?
Make the answer very short. 0.63. What is the ratio of the Imports (in Local Currency Unit) of Ukraine in 1991 to that in 1993?
Offer a very short reply. 0. What is the ratio of the Imports (in Local Currency Unit) of Iraq in 1991 to that in 1994?
Your response must be concise. 1. What is the ratio of the Imports (in Local Currency Unit) in Mali in 1991 to that in 1994?
Make the answer very short. 0.56. What is the ratio of the Imports (in Local Currency Unit) in Pakistan in 1991 to that in 1994?
Provide a short and direct response. 0.63. What is the ratio of the Imports (in Local Currency Unit) in Ukraine in 1991 to that in 1994?
Offer a very short reply. 0. What is the ratio of the Imports (in Local Currency Unit) in Iraq in 1991 to that in 1995?
Keep it short and to the point. 1.01. What is the ratio of the Imports (in Local Currency Unit) of Mali in 1991 to that in 1995?
Provide a succinct answer. 0.48. What is the ratio of the Imports (in Local Currency Unit) of Pakistan in 1991 to that in 1995?
Offer a very short reply. 0.52. What is the ratio of the Imports (in Local Currency Unit) in Ukraine in 1991 to that in 1995?
Make the answer very short. 0. What is the ratio of the Imports (in Local Currency Unit) in Iraq in 1991 to that in 1996?
Make the answer very short. 0.92. What is the ratio of the Imports (in Local Currency Unit) of Mali in 1991 to that in 1996?
Give a very brief answer. 0.5. What is the ratio of the Imports (in Local Currency Unit) of Pakistan in 1991 to that in 1996?
Make the answer very short. 0.42. What is the ratio of the Imports (in Local Currency Unit) in Iraq in 1992 to that in 1993?
Give a very brief answer. 1.02. What is the ratio of the Imports (in Local Currency Unit) of Mali in 1992 to that in 1993?
Your answer should be compact. 1.05. What is the ratio of the Imports (in Local Currency Unit) in Pakistan in 1992 to that in 1993?
Your answer should be compact. 0.83. What is the ratio of the Imports (in Local Currency Unit) of Ukraine in 1992 to that in 1993?
Make the answer very short. 0.03. What is the ratio of the Imports (in Local Currency Unit) in Iraq in 1992 to that in 1994?
Offer a very short reply. 1.45. What is the ratio of the Imports (in Local Currency Unit) in Mali in 1992 to that in 1994?
Your answer should be compact. 0.59. What is the ratio of the Imports (in Local Currency Unit) in Pakistan in 1992 to that in 1994?
Offer a terse response. 0.83. What is the ratio of the Imports (in Local Currency Unit) in Ukraine in 1992 to that in 1994?
Offer a very short reply. 0. What is the ratio of the Imports (in Local Currency Unit) in Iraq in 1992 to that in 1995?
Offer a very short reply. 1.47. What is the ratio of the Imports (in Local Currency Unit) in Mali in 1992 to that in 1995?
Your answer should be very brief. 0.51. What is the ratio of the Imports (in Local Currency Unit) in Pakistan in 1992 to that in 1995?
Keep it short and to the point. 0.68. What is the ratio of the Imports (in Local Currency Unit) of Iraq in 1992 to that in 1996?
Your answer should be very brief. 1.34. What is the ratio of the Imports (in Local Currency Unit) of Mali in 1992 to that in 1996?
Offer a terse response. 0.53. What is the ratio of the Imports (in Local Currency Unit) in Pakistan in 1992 to that in 1996?
Provide a short and direct response. 0.54. What is the ratio of the Imports (in Local Currency Unit) in Iraq in 1993 to that in 1994?
Offer a terse response. 1.42. What is the ratio of the Imports (in Local Currency Unit) in Mali in 1993 to that in 1994?
Provide a succinct answer. 0.57. What is the ratio of the Imports (in Local Currency Unit) in Ukraine in 1993 to that in 1994?
Provide a short and direct response. 0.08. What is the ratio of the Imports (in Local Currency Unit) of Iraq in 1993 to that in 1995?
Provide a succinct answer. 1.44. What is the ratio of the Imports (in Local Currency Unit) in Mali in 1993 to that in 1995?
Make the answer very short. 0.49. What is the ratio of the Imports (in Local Currency Unit) of Pakistan in 1993 to that in 1995?
Your response must be concise. 0.83. What is the ratio of the Imports (in Local Currency Unit) in Ukraine in 1993 to that in 1995?
Make the answer very short. 0.01. What is the ratio of the Imports (in Local Currency Unit) in Iraq in 1993 to that in 1996?
Your response must be concise. 1.31. What is the ratio of the Imports (in Local Currency Unit) of Mali in 1993 to that in 1996?
Your response must be concise. 0.51. What is the ratio of the Imports (in Local Currency Unit) of Pakistan in 1993 to that in 1996?
Provide a short and direct response. 0.66. What is the ratio of the Imports (in Local Currency Unit) in Ukraine in 1993 to that in 1996?
Keep it short and to the point. 0.01. What is the ratio of the Imports (in Local Currency Unit) in Iraq in 1994 to that in 1995?
Make the answer very short. 1.01. What is the ratio of the Imports (in Local Currency Unit) of Mali in 1994 to that in 1995?
Provide a short and direct response. 0.86. What is the ratio of the Imports (in Local Currency Unit) in Pakistan in 1994 to that in 1995?
Your answer should be compact. 0.82. What is the ratio of the Imports (in Local Currency Unit) of Ukraine in 1994 to that in 1995?
Your answer should be compact. 0.17. What is the ratio of the Imports (in Local Currency Unit) in Iraq in 1994 to that in 1996?
Offer a terse response. 0.92. What is the ratio of the Imports (in Local Currency Unit) in Mali in 1994 to that in 1996?
Provide a short and direct response. 0.89. What is the ratio of the Imports (in Local Currency Unit) in Pakistan in 1994 to that in 1996?
Your response must be concise. 0.65. What is the ratio of the Imports (in Local Currency Unit) in Ukraine in 1994 to that in 1996?
Provide a succinct answer. 0.12. What is the ratio of the Imports (in Local Currency Unit) of Iraq in 1995 to that in 1996?
Your answer should be compact. 0.91. What is the ratio of the Imports (in Local Currency Unit) of Mali in 1995 to that in 1996?
Ensure brevity in your answer.  1.04. What is the ratio of the Imports (in Local Currency Unit) of Pakistan in 1995 to that in 1996?
Your answer should be very brief. 0.8. What is the ratio of the Imports (in Local Currency Unit) of Ukraine in 1995 to that in 1996?
Your response must be concise. 0.7. What is the difference between the highest and the second highest Imports (in Local Currency Unit) of Iraq?
Give a very brief answer. 2.61e+09. What is the difference between the highest and the second highest Imports (in Local Currency Unit) of Mali?
Provide a succinct answer. 1.73e+1. What is the difference between the highest and the second highest Imports (in Local Currency Unit) in Pakistan?
Ensure brevity in your answer.  9.19e+1. What is the difference between the highest and the second highest Imports (in Local Currency Unit) in Ukraine?
Offer a very short reply. 1.20e+1. What is the difference between the highest and the lowest Imports (in Local Currency Unit) of Iraq?
Provide a short and direct response. 3.11e+09. What is the difference between the highest and the lowest Imports (in Local Currency Unit) of Mali?
Your answer should be compact. 2.70e+11. What is the difference between the highest and the lowest Imports (in Local Currency Unit) of Pakistan?
Provide a succinct answer. 2.66e+11. What is the difference between the highest and the lowest Imports (in Local Currency Unit) of Ukraine?
Offer a terse response. 3.93e+1. 